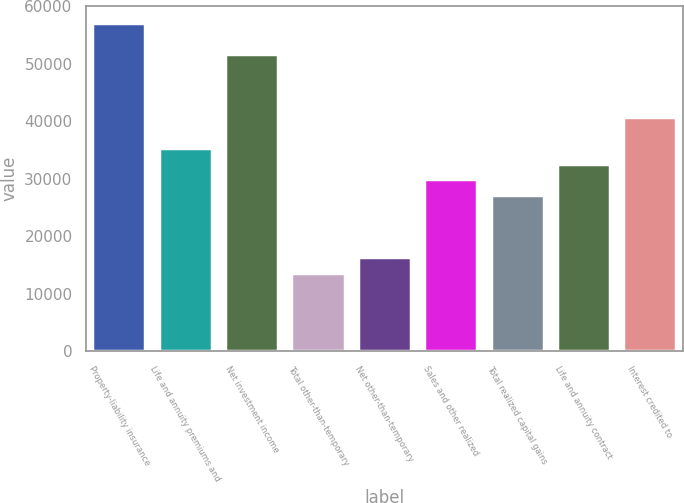Convert chart to OTSL. <chart><loc_0><loc_0><loc_500><loc_500><bar_chart><fcel>Property-liability insurance<fcel>Life and annuity premiums and<fcel>Net investment income<fcel>Total other-than-temporary<fcel>Net other-than-temporary<fcel>Sales and other realized<fcel>Total realized capital gains<fcel>Life and annuity contract<fcel>Interest credited to<nl><fcel>57187.7<fcel>35402.5<fcel>51741.4<fcel>13617.3<fcel>16340.4<fcel>29956.2<fcel>27233<fcel>32679.3<fcel>40848.8<nl></chart> 